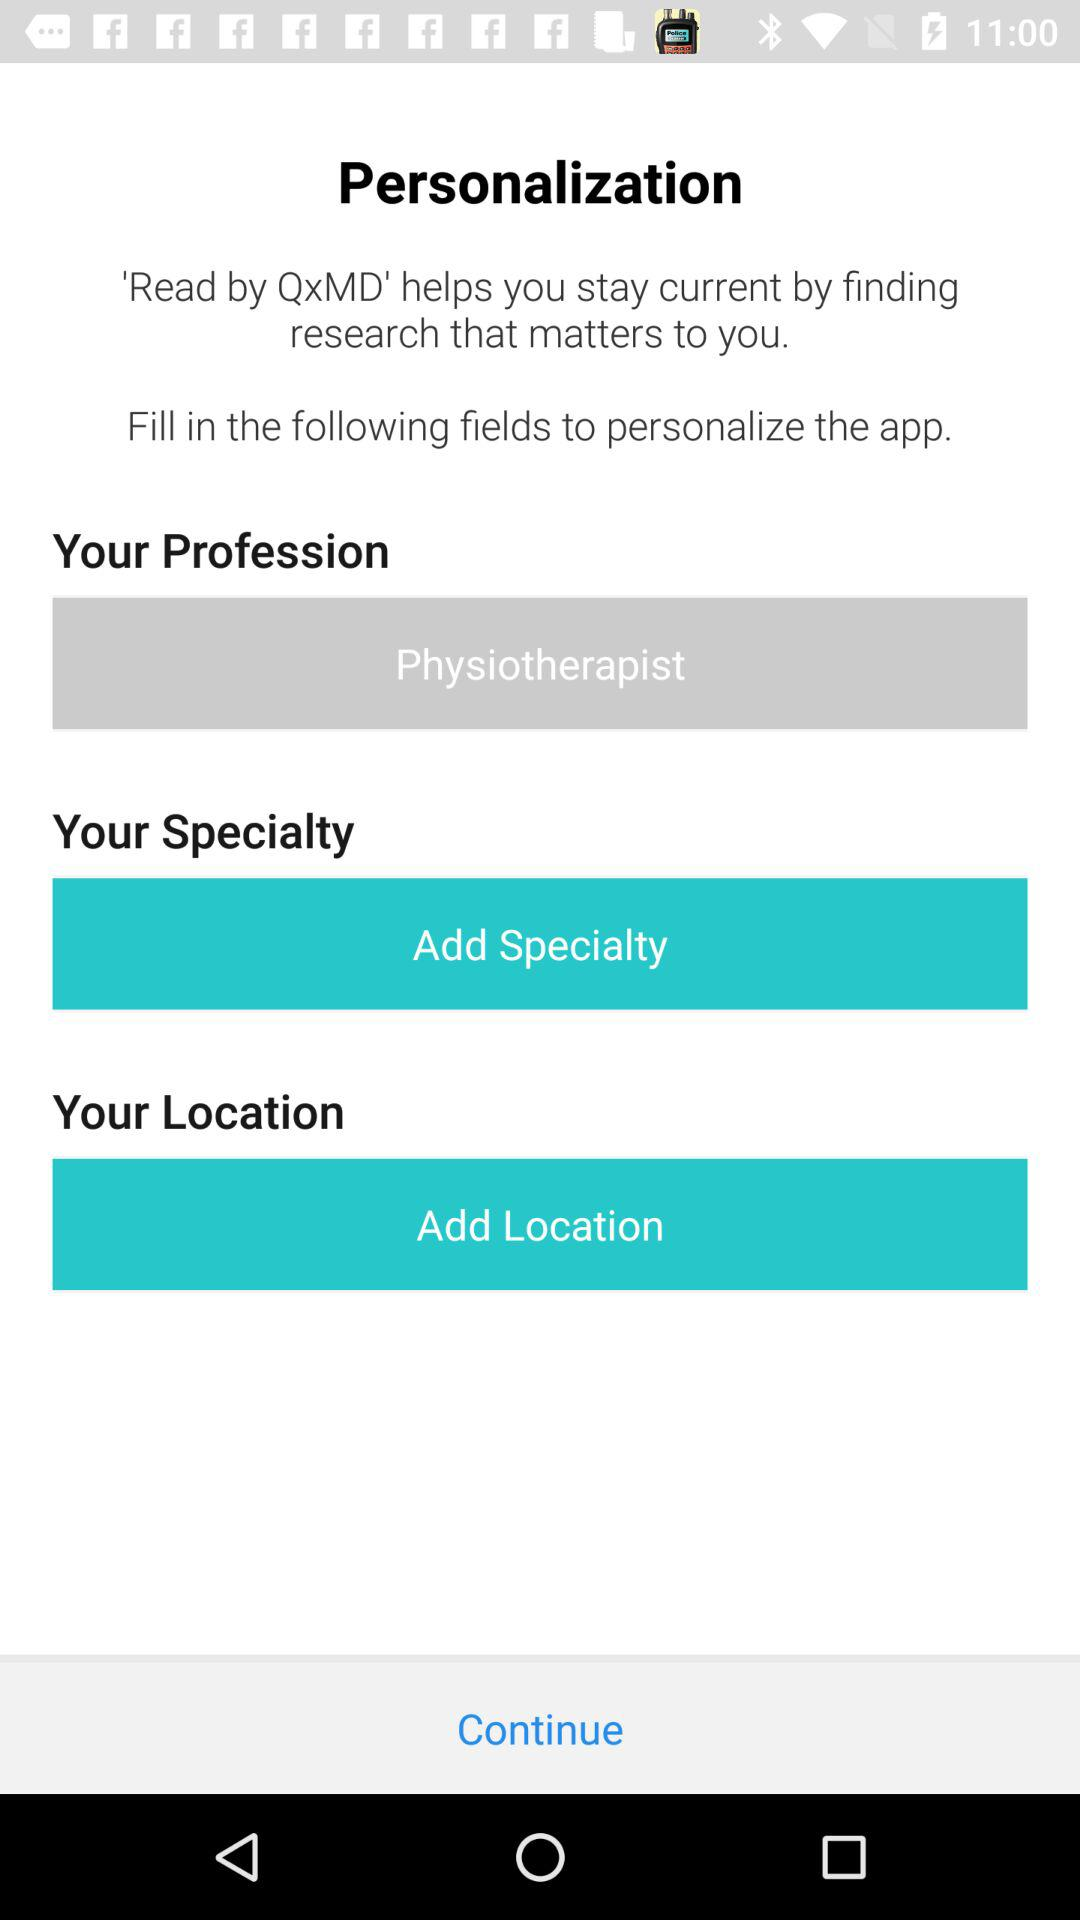What is the user's profession? The user is a physiotherapist. 